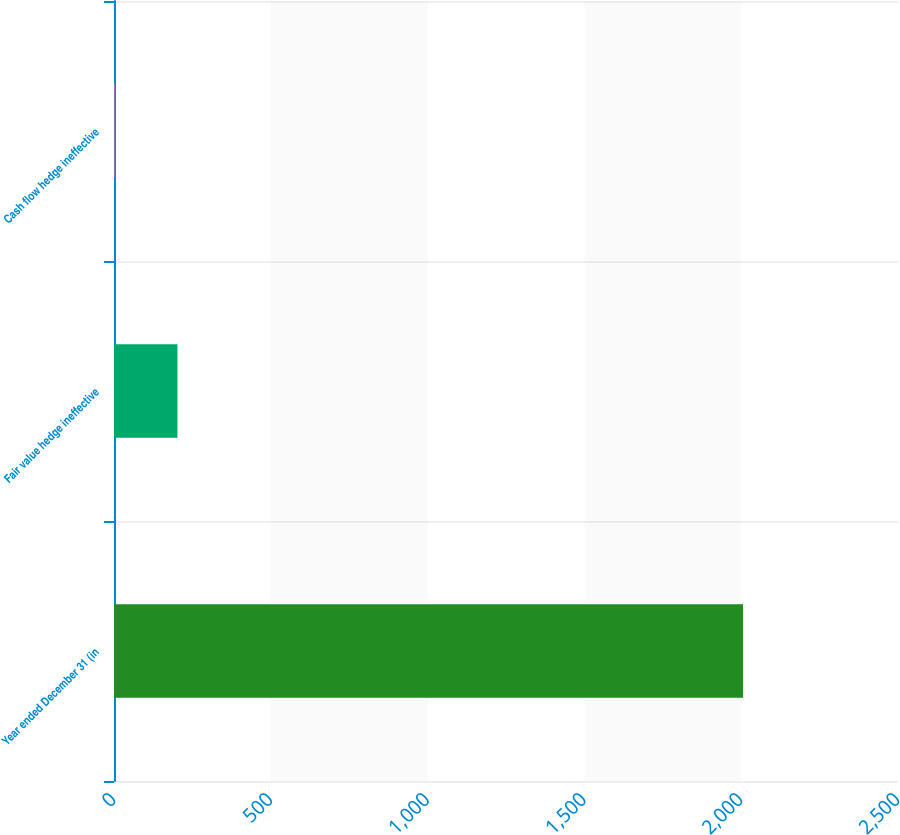<chart> <loc_0><loc_0><loc_500><loc_500><bar_chart><fcel>Year ended December 31 (in<fcel>Fair value hedge ineffective<fcel>Cash flow hedge ineffective<nl><fcel>2006<fcel>202.4<fcel>2<nl></chart> 